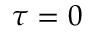Convert formula to latex. <formula><loc_0><loc_0><loc_500><loc_500>\tau = 0</formula> 